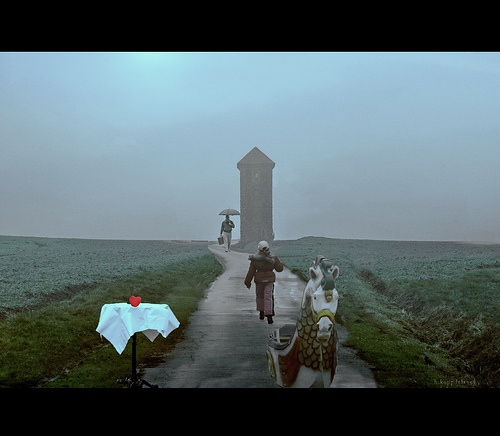Describe the objects in this image and their specific colors. I can see horse in black, gray, darkgray, and darkgreen tones, dining table in black, lightblue, and darkgray tones, people in black, gray, and darkgray tones, people in black, gray, and purple tones, and apple in black, brown, and maroon tones in this image. 